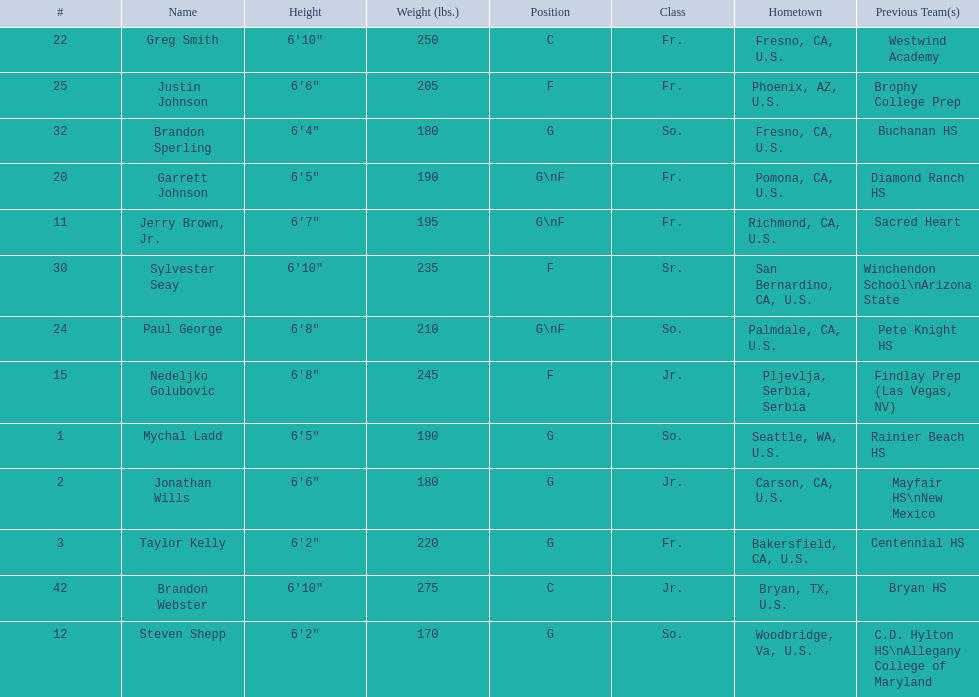Who are the players for the 2009-10 fresno state bulldogs men's basketball team? Mychal Ladd, Jonathan Wills, Taylor Kelly, Jerry Brown, Jr., Steven Shepp, Nedeljko Golubovic, Garrett Johnson, Greg Smith, Paul George, Justin Johnson, Sylvester Seay, Brandon Sperling, Brandon Webster. What are their heights? 6'5", 6'6", 6'2", 6'7", 6'2", 6'8", 6'5", 6'10", 6'8", 6'6", 6'10", 6'4", 6'10". What is the shortest height? 6'2", 6'2". What is the lowest weight? 6'2". Which player is it? Steven Shepp. 